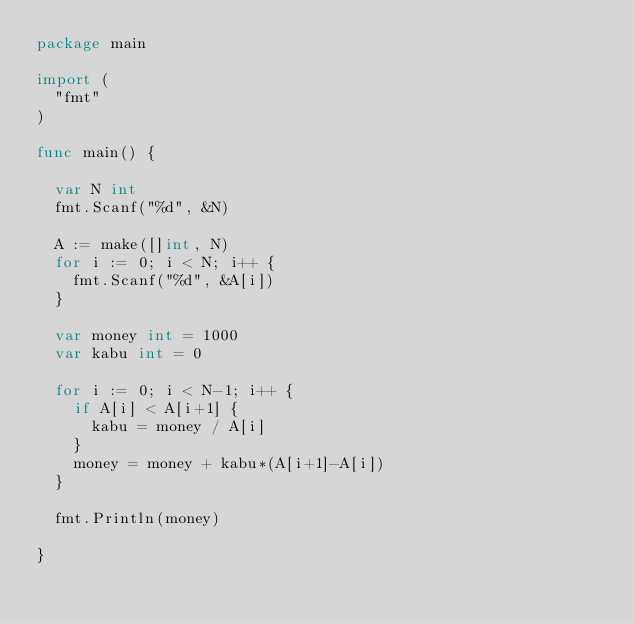<code> <loc_0><loc_0><loc_500><loc_500><_Go_>package main

import (
	"fmt"
)

func main() {

	var N int
	fmt.Scanf("%d", &N)

	A := make([]int, N)
	for i := 0; i < N; i++ {
		fmt.Scanf("%d", &A[i])
	}

	var money int = 1000
	var kabu int = 0

	for i := 0; i < N-1; i++ {
		if A[i] < A[i+1] {
			kabu = money / A[i]
		}
		money = money + kabu*(A[i+1]-A[i])
	}

	fmt.Println(money)

}
</code> 